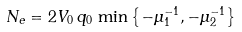<formula> <loc_0><loc_0><loc_500><loc_500>N _ { e } = 2 V _ { 0 } \, q _ { 0 } \, \min \left \{ - \mu _ { 1 } ^ { - 1 } , - \mu _ { 2 } ^ { - 1 } \right \}</formula> 